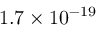<formula> <loc_0><loc_0><loc_500><loc_500>1 . 7 \times 1 0 ^ { - 1 9 }</formula> 